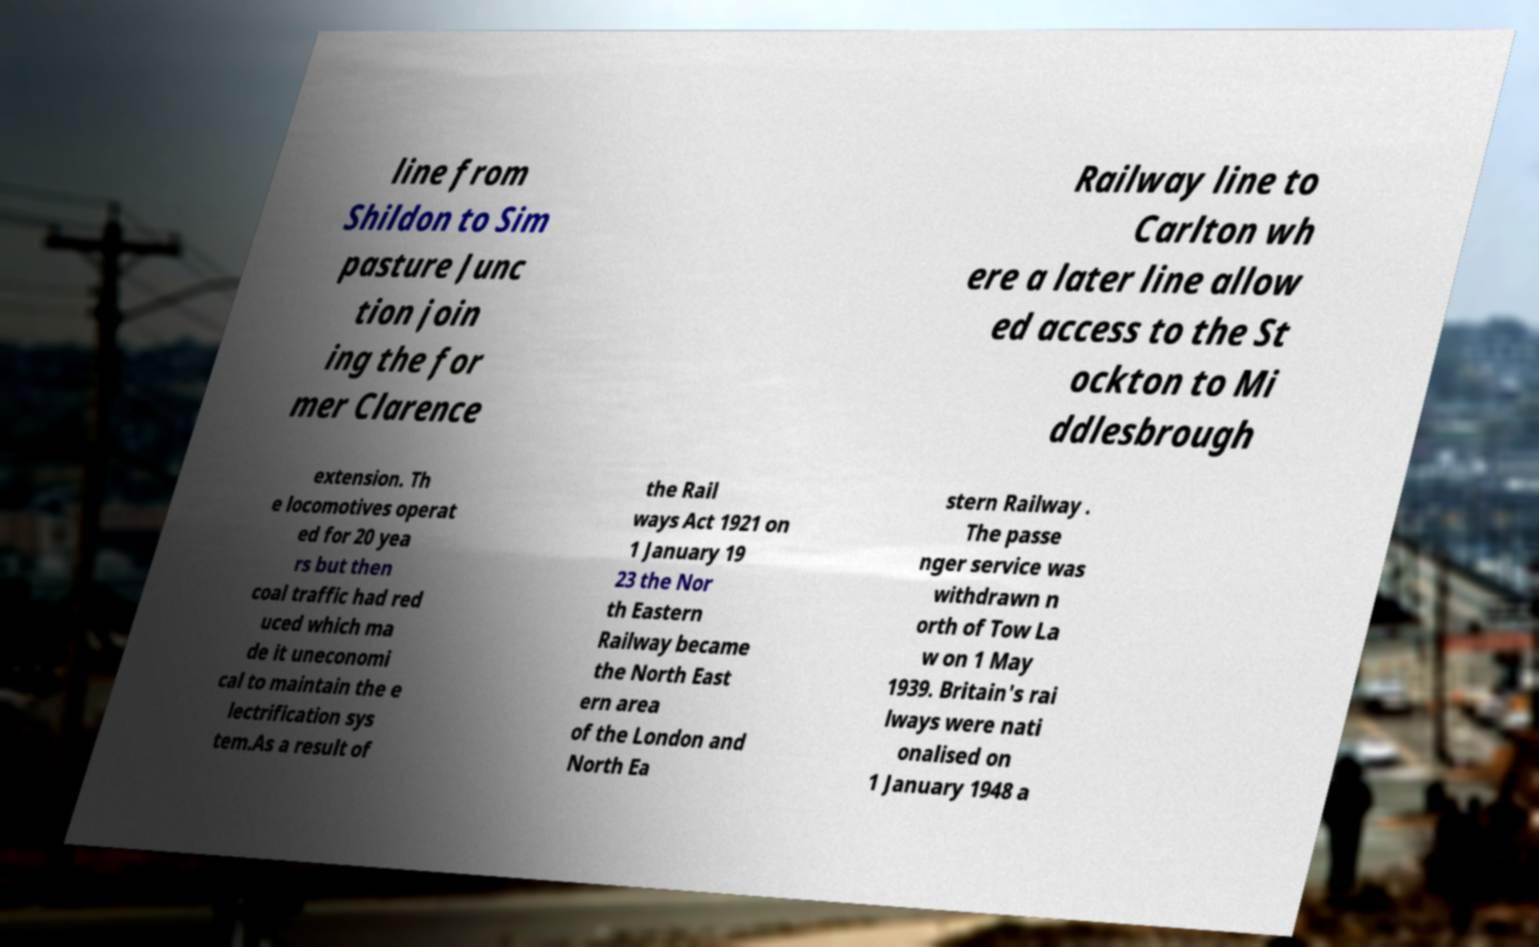There's text embedded in this image that I need extracted. Can you transcribe it verbatim? line from Shildon to Sim pasture Junc tion join ing the for mer Clarence Railway line to Carlton wh ere a later line allow ed access to the St ockton to Mi ddlesbrough extension. Th e locomotives operat ed for 20 yea rs but then coal traffic had red uced which ma de it uneconomi cal to maintain the e lectrification sys tem.As a result of the Rail ways Act 1921 on 1 January 19 23 the Nor th Eastern Railway became the North East ern area of the London and North Ea stern Railway . The passe nger service was withdrawn n orth of Tow La w on 1 May 1939. Britain's rai lways were nati onalised on 1 January 1948 a 